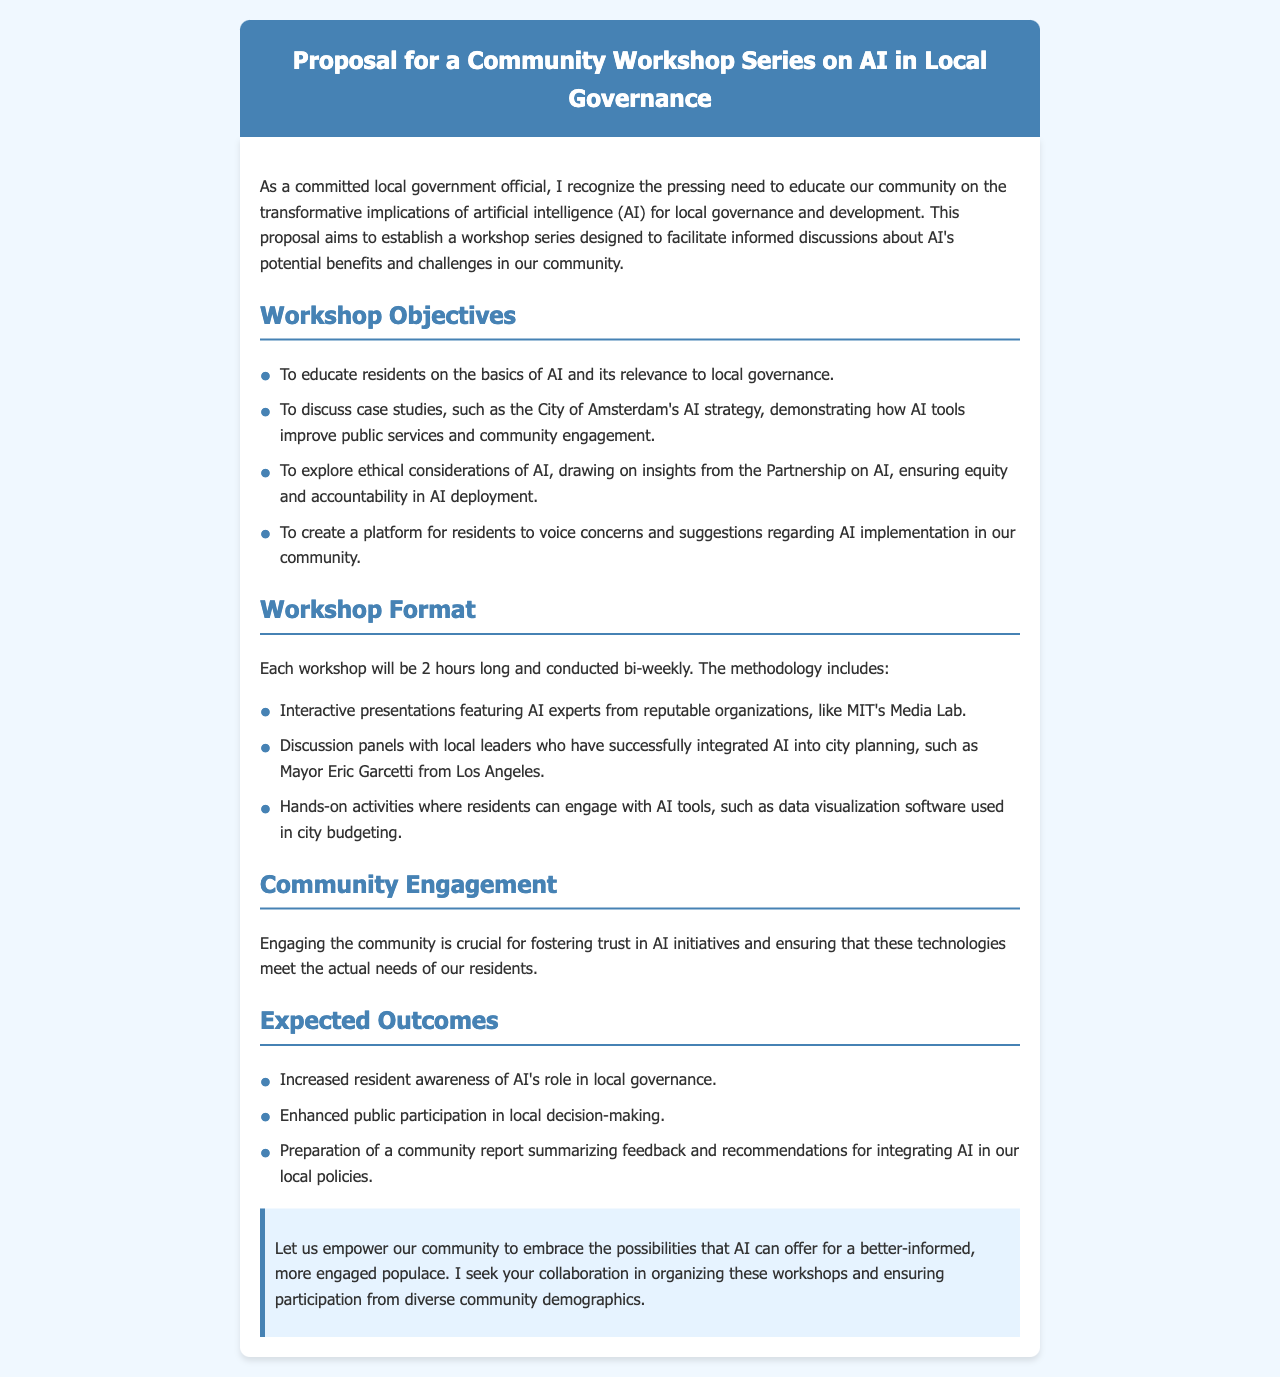What is the title of the proposal? The title of the proposal is clearly stated in the header of the document.
Answer: Proposal for a Community Workshop Series on AI in Local Governance How long will each workshop last? The document specifies the duration of each workshop.
Answer: 2 hours What is one of the workshop objectives? One of the workshop objectives is highlighted in the section outlining the goals of the workshop series.
Answer: To educate residents on the basics of AI and its relevance to local governance Who will lead the interactive presentations? The document mentions a reputable organization that will provide AI experts for the presentations.
Answer: MIT's Media Lab What type of activities will residents engage in? The document describes the nature of the engagement activities during the workshops.
Answer: Hands-on activities What is an expected outcome of the workshops? The expected outcomes are listed, providing specific insights into what the workshops aim to achieve.
Answer: Increased resident awareness of AI's role in local governance Which city's example is discussed in the proposal? The proposal references a case study that serves as an example for the workshop discussions.
Answer: City of Amsterdam Why is community engagement emphasized? The document explains the importance of engagement in relation to AI initiatives.
Answer: For fostering trust in AI initiatives 